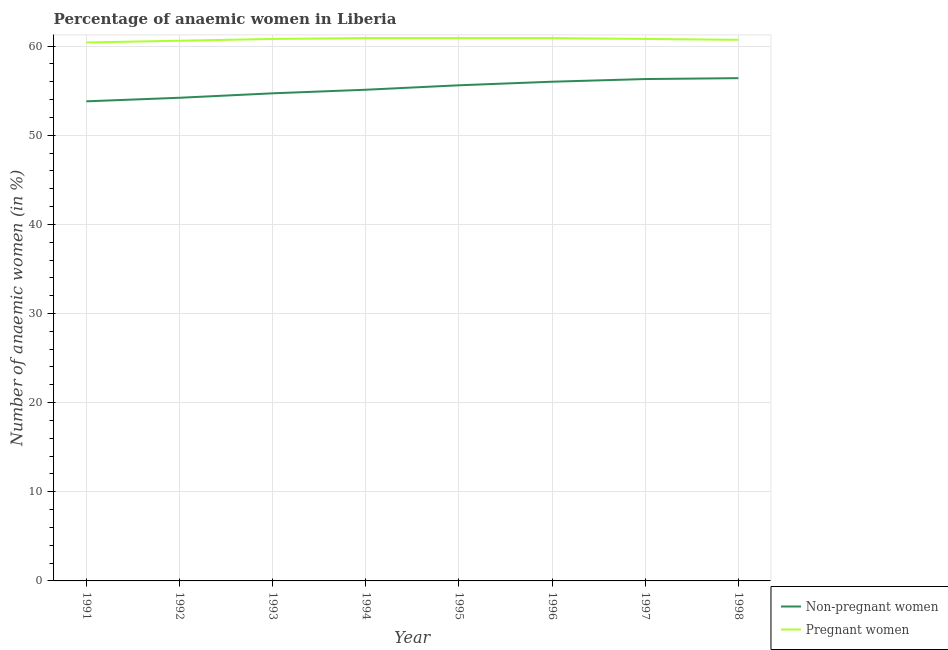Is the number of lines equal to the number of legend labels?
Offer a very short reply. Yes. What is the percentage of non-pregnant anaemic women in 1998?
Provide a succinct answer. 56.4. Across all years, what is the maximum percentage of non-pregnant anaemic women?
Give a very brief answer. 56.4. Across all years, what is the minimum percentage of non-pregnant anaemic women?
Your answer should be compact. 53.8. In which year was the percentage of non-pregnant anaemic women minimum?
Your answer should be compact. 1991. What is the total percentage of non-pregnant anaemic women in the graph?
Your response must be concise. 442.1. What is the difference between the percentage of non-pregnant anaemic women in 1991 and that in 1994?
Ensure brevity in your answer.  -1.3. What is the difference between the percentage of non-pregnant anaemic women in 1992 and the percentage of pregnant anaemic women in 1998?
Provide a succinct answer. -6.5. What is the average percentage of pregnant anaemic women per year?
Ensure brevity in your answer.  60.75. In the year 1996, what is the difference between the percentage of pregnant anaemic women and percentage of non-pregnant anaemic women?
Keep it short and to the point. 4.9. What is the ratio of the percentage of pregnant anaemic women in 1996 to that in 1998?
Your answer should be very brief. 1. What is the difference between the highest and the second highest percentage of pregnant anaemic women?
Provide a succinct answer. 0. What is the difference between the highest and the lowest percentage of pregnant anaemic women?
Your response must be concise. 0.5. In how many years, is the percentage of non-pregnant anaemic women greater than the average percentage of non-pregnant anaemic women taken over all years?
Ensure brevity in your answer.  4. Is the sum of the percentage of non-pregnant anaemic women in 1995 and 1998 greater than the maximum percentage of pregnant anaemic women across all years?
Your response must be concise. Yes. Is the percentage of non-pregnant anaemic women strictly less than the percentage of pregnant anaemic women over the years?
Offer a terse response. Yes. How many lines are there?
Provide a succinct answer. 2. What is the difference between two consecutive major ticks on the Y-axis?
Ensure brevity in your answer.  10. Where does the legend appear in the graph?
Keep it short and to the point. Bottom right. What is the title of the graph?
Offer a very short reply. Percentage of anaemic women in Liberia. Does "Pregnant women" appear as one of the legend labels in the graph?
Give a very brief answer. Yes. What is the label or title of the Y-axis?
Offer a terse response. Number of anaemic women (in %). What is the Number of anaemic women (in %) in Non-pregnant women in 1991?
Offer a very short reply. 53.8. What is the Number of anaemic women (in %) of Pregnant women in 1991?
Your response must be concise. 60.4. What is the Number of anaemic women (in %) of Non-pregnant women in 1992?
Your answer should be very brief. 54.2. What is the Number of anaemic women (in %) of Pregnant women in 1992?
Offer a very short reply. 60.6. What is the Number of anaemic women (in %) of Non-pregnant women in 1993?
Offer a very short reply. 54.7. What is the Number of anaemic women (in %) of Pregnant women in 1993?
Provide a succinct answer. 60.8. What is the Number of anaemic women (in %) of Non-pregnant women in 1994?
Your answer should be compact. 55.1. What is the Number of anaemic women (in %) of Pregnant women in 1994?
Offer a very short reply. 60.9. What is the Number of anaemic women (in %) of Non-pregnant women in 1995?
Your answer should be very brief. 55.6. What is the Number of anaemic women (in %) in Pregnant women in 1995?
Your response must be concise. 60.9. What is the Number of anaemic women (in %) of Non-pregnant women in 1996?
Make the answer very short. 56. What is the Number of anaemic women (in %) of Pregnant women in 1996?
Keep it short and to the point. 60.9. What is the Number of anaemic women (in %) of Non-pregnant women in 1997?
Your answer should be very brief. 56.3. What is the Number of anaemic women (in %) in Pregnant women in 1997?
Your answer should be compact. 60.8. What is the Number of anaemic women (in %) of Non-pregnant women in 1998?
Ensure brevity in your answer.  56.4. What is the Number of anaemic women (in %) of Pregnant women in 1998?
Offer a terse response. 60.7. Across all years, what is the maximum Number of anaemic women (in %) in Non-pregnant women?
Your answer should be compact. 56.4. Across all years, what is the maximum Number of anaemic women (in %) in Pregnant women?
Provide a short and direct response. 60.9. Across all years, what is the minimum Number of anaemic women (in %) in Non-pregnant women?
Ensure brevity in your answer.  53.8. Across all years, what is the minimum Number of anaemic women (in %) of Pregnant women?
Keep it short and to the point. 60.4. What is the total Number of anaemic women (in %) of Non-pregnant women in the graph?
Your answer should be compact. 442.1. What is the total Number of anaemic women (in %) in Pregnant women in the graph?
Provide a short and direct response. 486. What is the difference between the Number of anaemic women (in %) in Pregnant women in 1991 and that in 1992?
Provide a succinct answer. -0.2. What is the difference between the Number of anaemic women (in %) in Non-pregnant women in 1991 and that in 1993?
Ensure brevity in your answer.  -0.9. What is the difference between the Number of anaemic women (in %) in Pregnant women in 1991 and that in 1993?
Your response must be concise. -0.4. What is the difference between the Number of anaemic women (in %) in Pregnant women in 1991 and that in 1994?
Offer a terse response. -0.5. What is the difference between the Number of anaemic women (in %) of Non-pregnant women in 1991 and that in 1995?
Ensure brevity in your answer.  -1.8. What is the difference between the Number of anaemic women (in %) in Pregnant women in 1991 and that in 1995?
Make the answer very short. -0.5. What is the difference between the Number of anaemic women (in %) in Non-pregnant women in 1991 and that in 1996?
Your answer should be very brief. -2.2. What is the difference between the Number of anaemic women (in %) in Pregnant women in 1991 and that in 1996?
Provide a short and direct response. -0.5. What is the difference between the Number of anaemic women (in %) in Non-pregnant women in 1991 and that in 1997?
Ensure brevity in your answer.  -2.5. What is the difference between the Number of anaemic women (in %) of Pregnant women in 1991 and that in 1997?
Ensure brevity in your answer.  -0.4. What is the difference between the Number of anaemic women (in %) of Non-pregnant women in 1991 and that in 1998?
Keep it short and to the point. -2.6. What is the difference between the Number of anaemic women (in %) in Non-pregnant women in 1992 and that in 1993?
Give a very brief answer. -0.5. What is the difference between the Number of anaemic women (in %) of Pregnant women in 1992 and that in 1993?
Offer a terse response. -0.2. What is the difference between the Number of anaemic women (in %) of Non-pregnant women in 1992 and that in 1995?
Ensure brevity in your answer.  -1.4. What is the difference between the Number of anaemic women (in %) in Non-pregnant women in 1992 and that in 1996?
Provide a succinct answer. -1.8. What is the difference between the Number of anaemic women (in %) of Non-pregnant women in 1992 and that in 1997?
Make the answer very short. -2.1. What is the difference between the Number of anaemic women (in %) of Pregnant women in 1992 and that in 1997?
Your response must be concise. -0.2. What is the difference between the Number of anaemic women (in %) of Pregnant women in 1992 and that in 1998?
Your response must be concise. -0.1. What is the difference between the Number of anaemic women (in %) in Pregnant women in 1993 and that in 1994?
Provide a succinct answer. -0.1. What is the difference between the Number of anaemic women (in %) of Pregnant women in 1993 and that in 1995?
Your response must be concise. -0.1. What is the difference between the Number of anaemic women (in %) of Non-pregnant women in 1993 and that in 1998?
Offer a very short reply. -1.7. What is the difference between the Number of anaemic women (in %) of Pregnant women in 1993 and that in 1998?
Provide a succinct answer. 0.1. What is the difference between the Number of anaemic women (in %) of Non-pregnant women in 1994 and that in 1995?
Ensure brevity in your answer.  -0.5. What is the difference between the Number of anaemic women (in %) of Pregnant women in 1994 and that in 1996?
Provide a succinct answer. 0. What is the difference between the Number of anaemic women (in %) of Pregnant women in 1994 and that in 1997?
Provide a short and direct response. 0.1. What is the difference between the Number of anaemic women (in %) in Pregnant women in 1994 and that in 1998?
Ensure brevity in your answer.  0.2. What is the difference between the Number of anaemic women (in %) in Non-pregnant women in 1995 and that in 1996?
Provide a short and direct response. -0.4. What is the difference between the Number of anaemic women (in %) in Pregnant women in 1995 and that in 1996?
Give a very brief answer. 0. What is the difference between the Number of anaemic women (in %) in Non-pregnant women in 1995 and that in 1997?
Give a very brief answer. -0.7. What is the difference between the Number of anaemic women (in %) in Pregnant women in 1995 and that in 1998?
Provide a succinct answer. 0.2. What is the difference between the Number of anaemic women (in %) of Non-pregnant women in 1996 and that in 1997?
Provide a short and direct response. -0.3. What is the difference between the Number of anaemic women (in %) in Pregnant women in 1996 and that in 1998?
Your answer should be compact. 0.2. What is the difference between the Number of anaemic women (in %) of Non-pregnant women in 1997 and that in 1998?
Provide a short and direct response. -0.1. What is the difference between the Number of anaemic women (in %) of Non-pregnant women in 1991 and the Number of anaemic women (in %) of Pregnant women in 1996?
Your answer should be compact. -7.1. What is the difference between the Number of anaemic women (in %) in Non-pregnant women in 1992 and the Number of anaemic women (in %) in Pregnant women in 1998?
Keep it short and to the point. -6.5. What is the difference between the Number of anaemic women (in %) of Non-pregnant women in 1993 and the Number of anaemic women (in %) of Pregnant women in 1995?
Make the answer very short. -6.2. What is the difference between the Number of anaemic women (in %) in Non-pregnant women in 1993 and the Number of anaemic women (in %) in Pregnant women in 1996?
Keep it short and to the point. -6.2. What is the difference between the Number of anaemic women (in %) in Non-pregnant women in 1993 and the Number of anaemic women (in %) in Pregnant women in 1997?
Make the answer very short. -6.1. What is the difference between the Number of anaemic women (in %) of Non-pregnant women in 1993 and the Number of anaemic women (in %) of Pregnant women in 1998?
Provide a short and direct response. -6. What is the difference between the Number of anaemic women (in %) in Non-pregnant women in 1994 and the Number of anaemic women (in %) in Pregnant women in 1997?
Offer a terse response. -5.7. What is the difference between the Number of anaemic women (in %) of Non-pregnant women in 1994 and the Number of anaemic women (in %) of Pregnant women in 1998?
Keep it short and to the point. -5.6. What is the difference between the Number of anaemic women (in %) in Non-pregnant women in 1995 and the Number of anaemic women (in %) in Pregnant women in 1996?
Offer a terse response. -5.3. What is the difference between the Number of anaemic women (in %) of Non-pregnant women in 1995 and the Number of anaemic women (in %) of Pregnant women in 1997?
Your response must be concise. -5.2. What is the average Number of anaemic women (in %) in Non-pregnant women per year?
Give a very brief answer. 55.26. What is the average Number of anaemic women (in %) in Pregnant women per year?
Provide a succinct answer. 60.75. In the year 1991, what is the difference between the Number of anaemic women (in %) of Non-pregnant women and Number of anaemic women (in %) of Pregnant women?
Your answer should be very brief. -6.6. In the year 1992, what is the difference between the Number of anaemic women (in %) of Non-pregnant women and Number of anaemic women (in %) of Pregnant women?
Make the answer very short. -6.4. In the year 1994, what is the difference between the Number of anaemic women (in %) in Non-pregnant women and Number of anaemic women (in %) in Pregnant women?
Provide a short and direct response. -5.8. In the year 1998, what is the difference between the Number of anaemic women (in %) in Non-pregnant women and Number of anaemic women (in %) in Pregnant women?
Ensure brevity in your answer.  -4.3. What is the ratio of the Number of anaemic women (in %) in Non-pregnant women in 1991 to that in 1993?
Your answer should be very brief. 0.98. What is the ratio of the Number of anaemic women (in %) in Non-pregnant women in 1991 to that in 1994?
Provide a succinct answer. 0.98. What is the ratio of the Number of anaemic women (in %) of Pregnant women in 1991 to that in 1994?
Offer a terse response. 0.99. What is the ratio of the Number of anaemic women (in %) of Non-pregnant women in 1991 to that in 1995?
Keep it short and to the point. 0.97. What is the ratio of the Number of anaemic women (in %) of Pregnant women in 1991 to that in 1995?
Provide a short and direct response. 0.99. What is the ratio of the Number of anaemic women (in %) of Non-pregnant women in 1991 to that in 1996?
Ensure brevity in your answer.  0.96. What is the ratio of the Number of anaemic women (in %) of Non-pregnant women in 1991 to that in 1997?
Ensure brevity in your answer.  0.96. What is the ratio of the Number of anaemic women (in %) in Pregnant women in 1991 to that in 1997?
Provide a succinct answer. 0.99. What is the ratio of the Number of anaemic women (in %) in Non-pregnant women in 1991 to that in 1998?
Give a very brief answer. 0.95. What is the ratio of the Number of anaemic women (in %) in Non-pregnant women in 1992 to that in 1993?
Offer a terse response. 0.99. What is the ratio of the Number of anaemic women (in %) of Pregnant women in 1992 to that in 1993?
Offer a terse response. 1. What is the ratio of the Number of anaemic women (in %) of Non-pregnant women in 1992 to that in 1994?
Give a very brief answer. 0.98. What is the ratio of the Number of anaemic women (in %) in Pregnant women in 1992 to that in 1994?
Your response must be concise. 1. What is the ratio of the Number of anaemic women (in %) in Non-pregnant women in 1992 to that in 1995?
Ensure brevity in your answer.  0.97. What is the ratio of the Number of anaemic women (in %) in Non-pregnant women in 1992 to that in 1996?
Your response must be concise. 0.97. What is the ratio of the Number of anaemic women (in %) in Pregnant women in 1992 to that in 1996?
Offer a terse response. 1. What is the ratio of the Number of anaemic women (in %) of Non-pregnant women in 1992 to that in 1997?
Offer a very short reply. 0.96. What is the ratio of the Number of anaemic women (in %) of Pregnant women in 1993 to that in 1994?
Make the answer very short. 1. What is the ratio of the Number of anaemic women (in %) in Non-pregnant women in 1993 to that in 1995?
Give a very brief answer. 0.98. What is the ratio of the Number of anaemic women (in %) of Pregnant women in 1993 to that in 1995?
Offer a very short reply. 1. What is the ratio of the Number of anaemic women (in %) of Non-pregnant women in 1993 to that in 1996?
Your answer should be very brief. 0.98. What is the ratio of the Number of anaemic women (in %) in Pregnant women in 1993 to that in 1996?
Your answer should be compact. 1. What is the ratio of the Number of anaemic women (in %) of Non-pregnant women in 1993 to that in 1997?
Make the answer very short. 0.97. What is the ratio of the Number of anaemic women (in %) of Non-pregnant women in 1993 to that in 1998?
Keep it short and to the point. 0.97. What is the ratio of the Number of anaemic women (in %) in Non-pregnant women in 1994 to that in 1996?
Give a very brief answer. 0.98. What is the ratio of the Number of anaemic women (in %) in Pregnant women in 1994 to that in 1996?
Offer a very short reply. 1. What is the ratio of the Number of anaemic women (in %) in Non-pregnant women in 1994 to that in 1997?
Provide a succinct answer. 0.98. What is the ratio of the Number of anaemic women (in %) in Pregnant women in 1994 to that in 1997?
Provide a short and direct response. 1. What is the ratio of the Number of anaemic women (in %) of Non-pregnant women in 1994 to that in 1998?
Your answer should be compact. 0.98. What is the ratio of the Number of anaemic women (in %) of Pregnant women in 1994 to that in 1998?
Keep it short and to the point. 1. What is the ratio of the Number of anaemic women (in %) in Non-pregnant women in 1995 to that in 1996?
Offer a very short reply. 0.99. What is the ratio of the Number of anaemic women (in %) in Pregnant women in 1995 to that in 1996?
Give a very brief answer. 1. What is the ratio of the Number of anaemic women (in %) of Non-pregnant women in 1995 to that in 1997?
Keep it short and to the point. 0.99. What is the ratio of the Number of anaemic women (in %) in Non-pregnant women in 1995 to that in 1998?
Your answer should be compact. 0.99. What is the ratio of the Number of anaemic women (in %) in Pregnant women in 1995 to that in 1998?
Offer a terse response. 1. What is the ratio of the Number of anaemic women (in %) in Non-pregnant women in 1996 to that in 1997?
Provide a succinct answer. 0.99. What is the ratio of the Number of anaemic women (in %) of Pregnant women in 1996 to that in 1997?
Your answer should be compact. 1. What is the ratio of the Number of anaemic women (in %) in Non-pregnant women in 1996 to that in 1998?
Ensure brevity in your answer.  0.99. What is the ratio of the Number of anaemic women (in %) in Pregnant women in 1996 to that in 1998?
Make the answer very short. 1. What is the difference between the highest and the second highest Number of anaemic women (in %) in Non-pregnant women?
Make the answer very short. 0.1. 